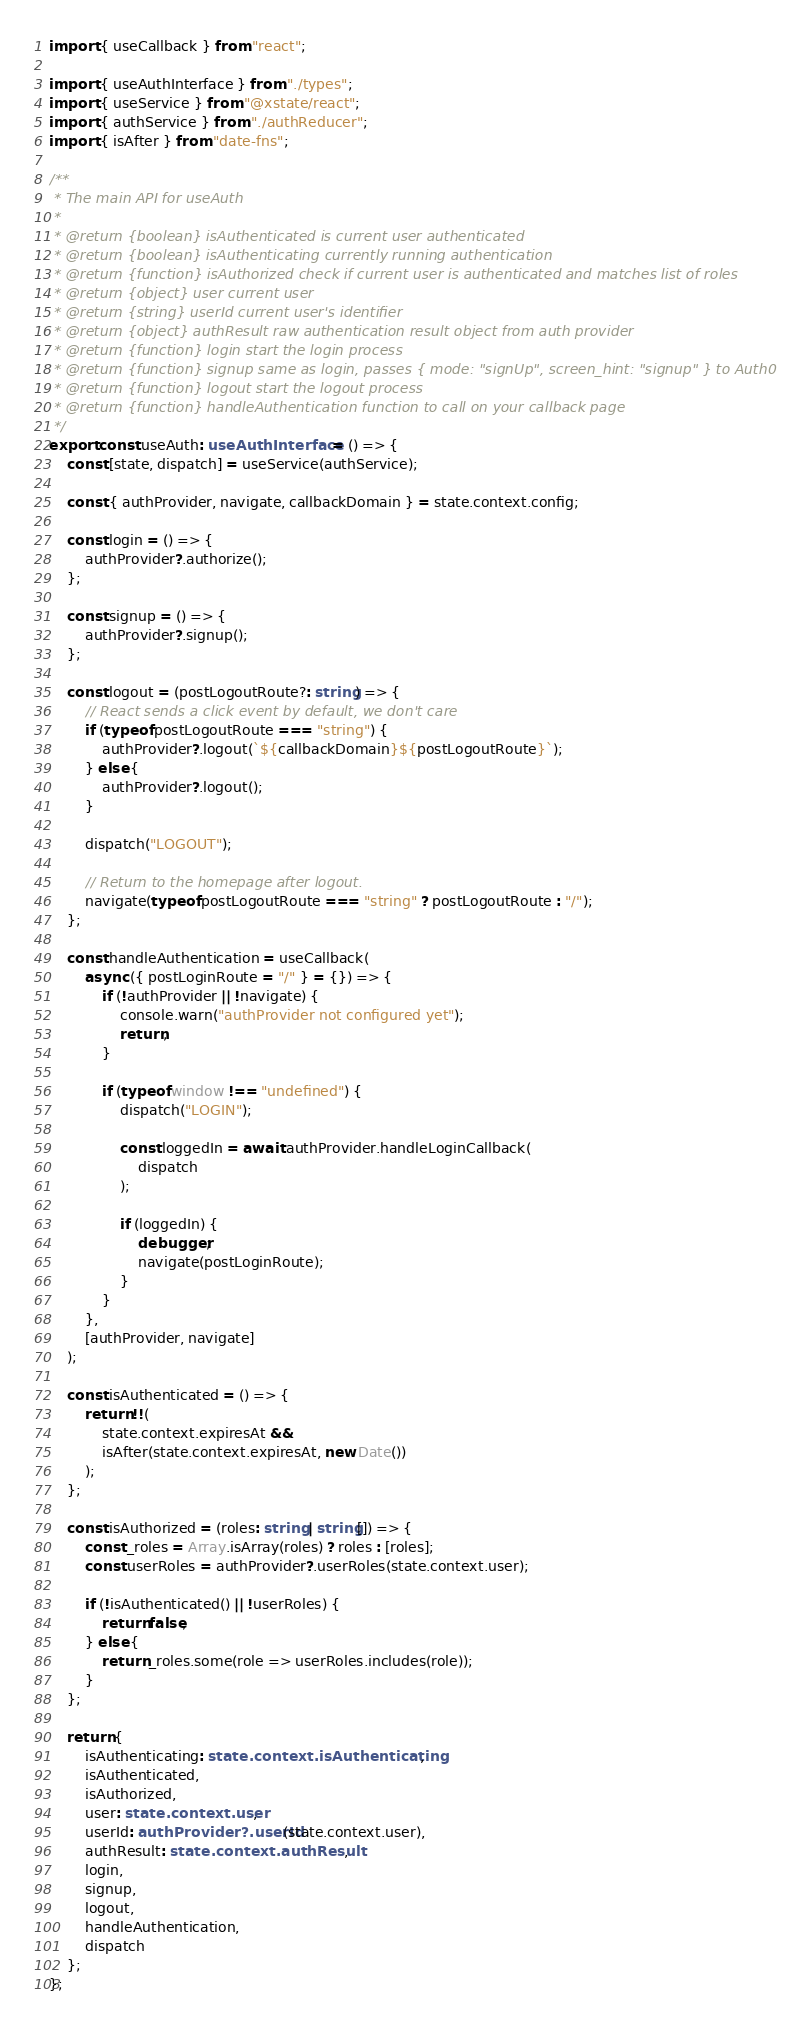<code> <loc_0><loc_0><loc_500><loc_500><_TypeScript_>import { useCallback } from "react";

import { useAuthInterface } from "./types";
import { useService } from "@xstate/react";
import { authService } from "./authReducer";
import { isAfter } from "date-fns";

/**
 * The main API for useAuth
 *
 * @return {boolean} isAuthenticated is current user authenticated
 * @return {boolean} isAuthenticating currently running authentication
 * @return {function} isAuthorized check if current user is authenticated and matches list of roles
 * @return {object} user current user
 * @return {string} userId current user's identifier
 * @return {object} authResult raw authentication result object from auth provider
 * @return {function} login start the login process
 * @return {function} signup same as login, passes { mode: "signUp", screen_hint: "signup" } to Auth0
 * @return {function} logout start the logout process
 * @return {function} handleAuthentication function to call on your callback page
 */
export const useAuth: useAuthInterface = () => {
    const [state, dispatch] = useService(authService);

    const { authProvider, navigate, callbackDomain } = state.context.config;

    const login = () => {
        authProvider?.authorize();
    };

    const signup = () => {
        authProvider?.signup();
    };

    const logout = (postLogoutRoute?: string) => {
        // React sends a click event by default, we don't care
        if (typeof postLogoutRoute === "string") {
            authProvider?.logout(`${callbackDomain}${postLogoutRoute}`);
        } else {
            authProvider?.logout();
        }

        dispatch("LOGOUT");

        // Return to the homepage after logout.
        navigate(typeof postLogoutRoute === "string" ? postLogoutRoute : "/");
    };

    const handleAuthentication = useCallback(
        async ({ postLoginRoute = "/" } = {}) => {
            if (!authProvider || !navigate) {
                console.warn("authProvider not configured yet");
                return;
            }

            if (typeof window !== "undefined") {
                dispatch("LOGIN");

                const loggedIn = await authProvider.handleLoginCallback(
                    dispatch
                );

                if (loggedIn) {
                    debugger;
                    navigate(postLoginRoute);
                }
            }
        },
        [authProvider, navigate]
    );

    const isAuthenticated = () => {
        return !!(
            state.context.expiresAt &&
            isAfter(state.context.expiresAt, new Date())
        );
    };

    const isAuthorized = (roles: string | string[]) => {
        const _roles = Array.isArray(roles) ? roles : [roles];
        const userRoles = authProvider?.userRoles(state.context.user);

        if (!isAuthenticated() || !userRoles) {
            return false;
        } else {
            return _roles.some(role => userRoles.includes(role));
        }
    };

    return {
        isAuthenticating: state.context.isAuthenticating,
        isAuthenticated,
        isAuthorized,
        user: state.context.user,
        userId: authProvider?.userId(state.context.user),
        authResult: state.context.authResult,
        login,
        signup,
        logout,
        handleAuthentication,
        dispatch
    };
};
</code> 